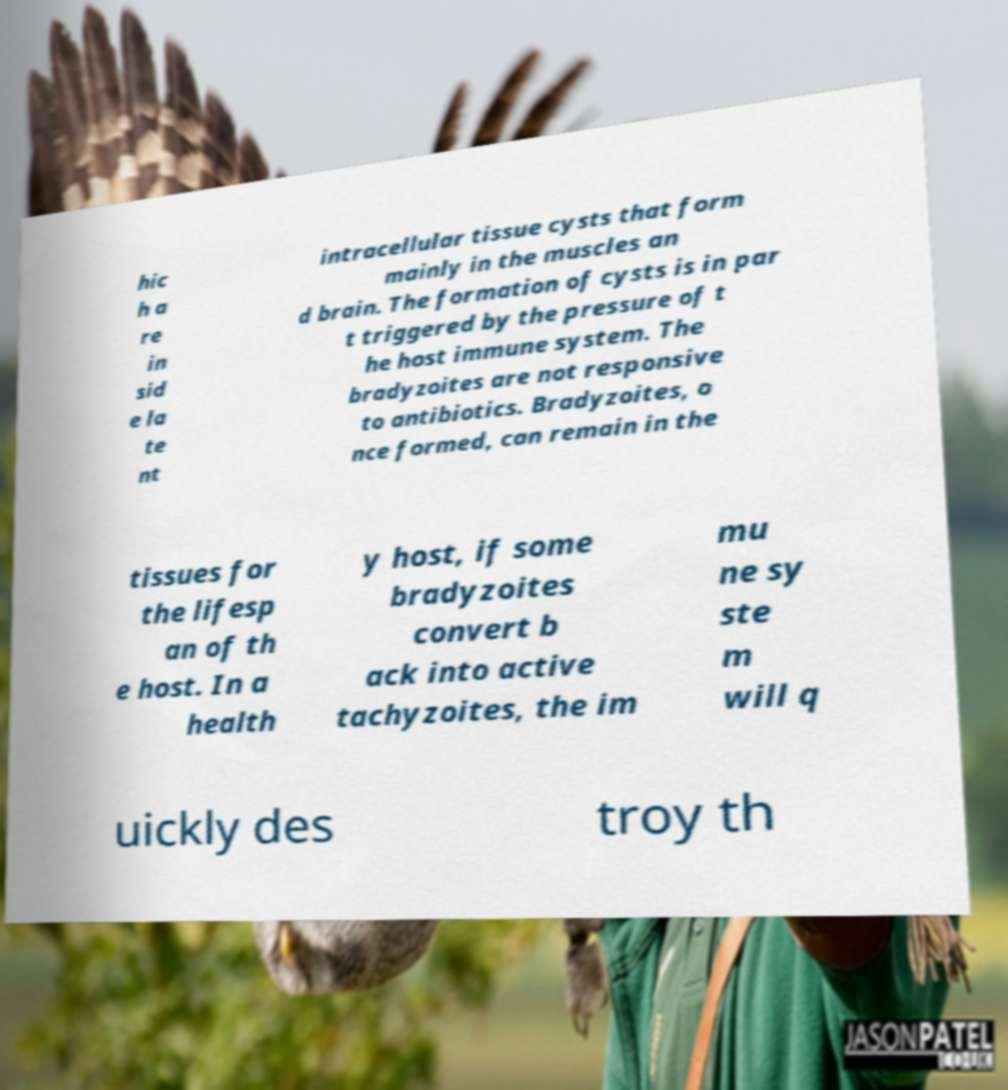Please read and relay the text visible in this image. What does it say? hic h a re in sid e la te nt intracellular tissue cysts that form mainly in the muscles an d brain. The formation of cysts is in par t triggered by the pressure of t he host immune system. The bradyzoites are not responsive to antibiotics. Bradyzoites, o nce formed, can remain in the tissues for the lifesp an of th e host. In a health y host, if some bradyzoites convert b ack into active tachyzoites, the im mu ne sy ste m will q uickly des troy th 